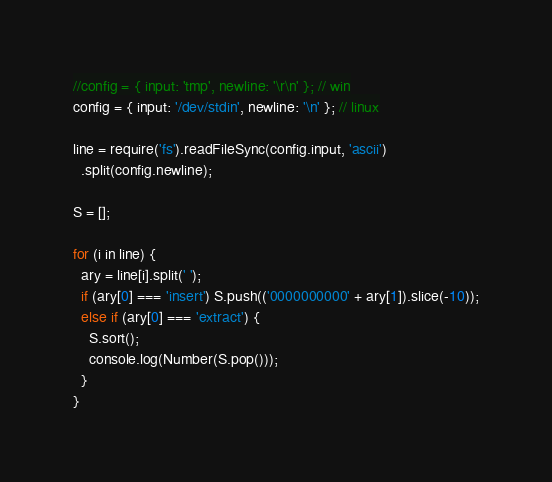Convert code to text. <code><loc_0><loc_0><loc_500><loc_500><_JavaScript_>//config = { input: 'tmp', newline: '\r\n' }; // win
config = { input: '/dev/stdin', newline: '\n' }; // linux

line = require('fs').readFileSync(config.input, 'ascii')
  .split(config.newline);

S = [];

for (i in line) {
  ary = line[i].split(' ');
  if (ary[0] === 'insert') S.push(('0000000000' + ary[1]).slice(-10));
  else if (ary[0] === 'extract') {
    S.sort();
    console.log(Number(S.pop()));
  }
}</code> 